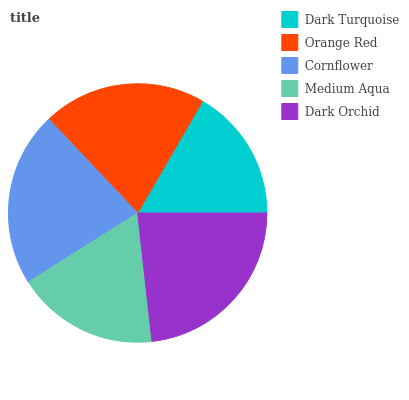Is Dark Turquoise the minimum?
Answer yes or no. Yes. Is Dark Orchid the maximum?
Answer yes or no. Yes. Is Orange Red the minimum?
Answer yes or no. No. Is Orange Red the maximum?
Answer yes or no. No. Is Orange Red greater than Dark Turquoise?
Answer yes or no. Yes. Is Dark Turquoise less than Orange Red?
Answer yes or no. Yes. Is Dark Turquoise greater than Orange Red?
Answer yes or no. No. Is Orange Red less than Dark Turquoise?
Answer yes or no. No. Is Orange Red the high median?
Answer yes or no. Yes. Is Orange Red the low median?
Answer yes or no. Yes. Is Dark Orchid the high median?
Answer yes or no. No. Is Medium Aqua the low median?
Answer yes or no. No. 